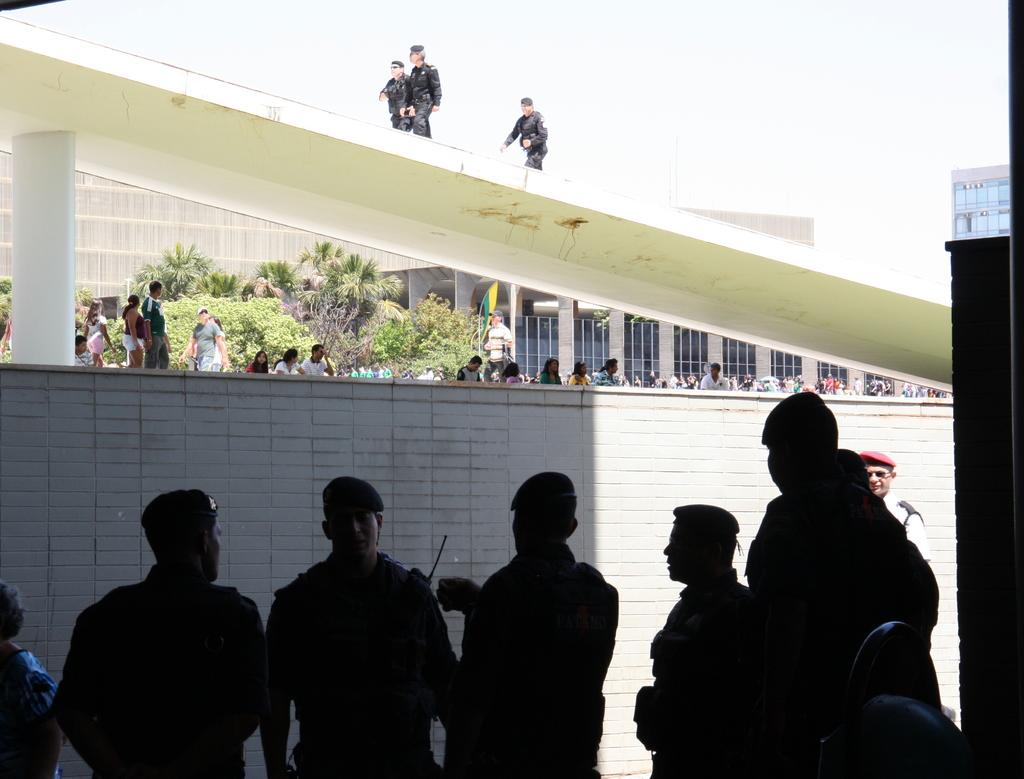What is happening in the foreground of the picture? There are people standing in the foreground of the picture. What is located behind the people in the foreground? There is a wall behind the people in the foreground. What can be seen in the center of the picture? In the center of the picture, there are people, trees, and a building. What architectural feature is present in the center of the picture? There is a bridge in the center of the picture. How would you describe the weather in the image? The sky is sunny, indicating a clear and likely warm day. Where is the cactus located in the image? There is no cactus present in the image. What type of tank is visible in the center of the picture? There is no tank present in the image; it features a bridge, people, trees, and a building. 